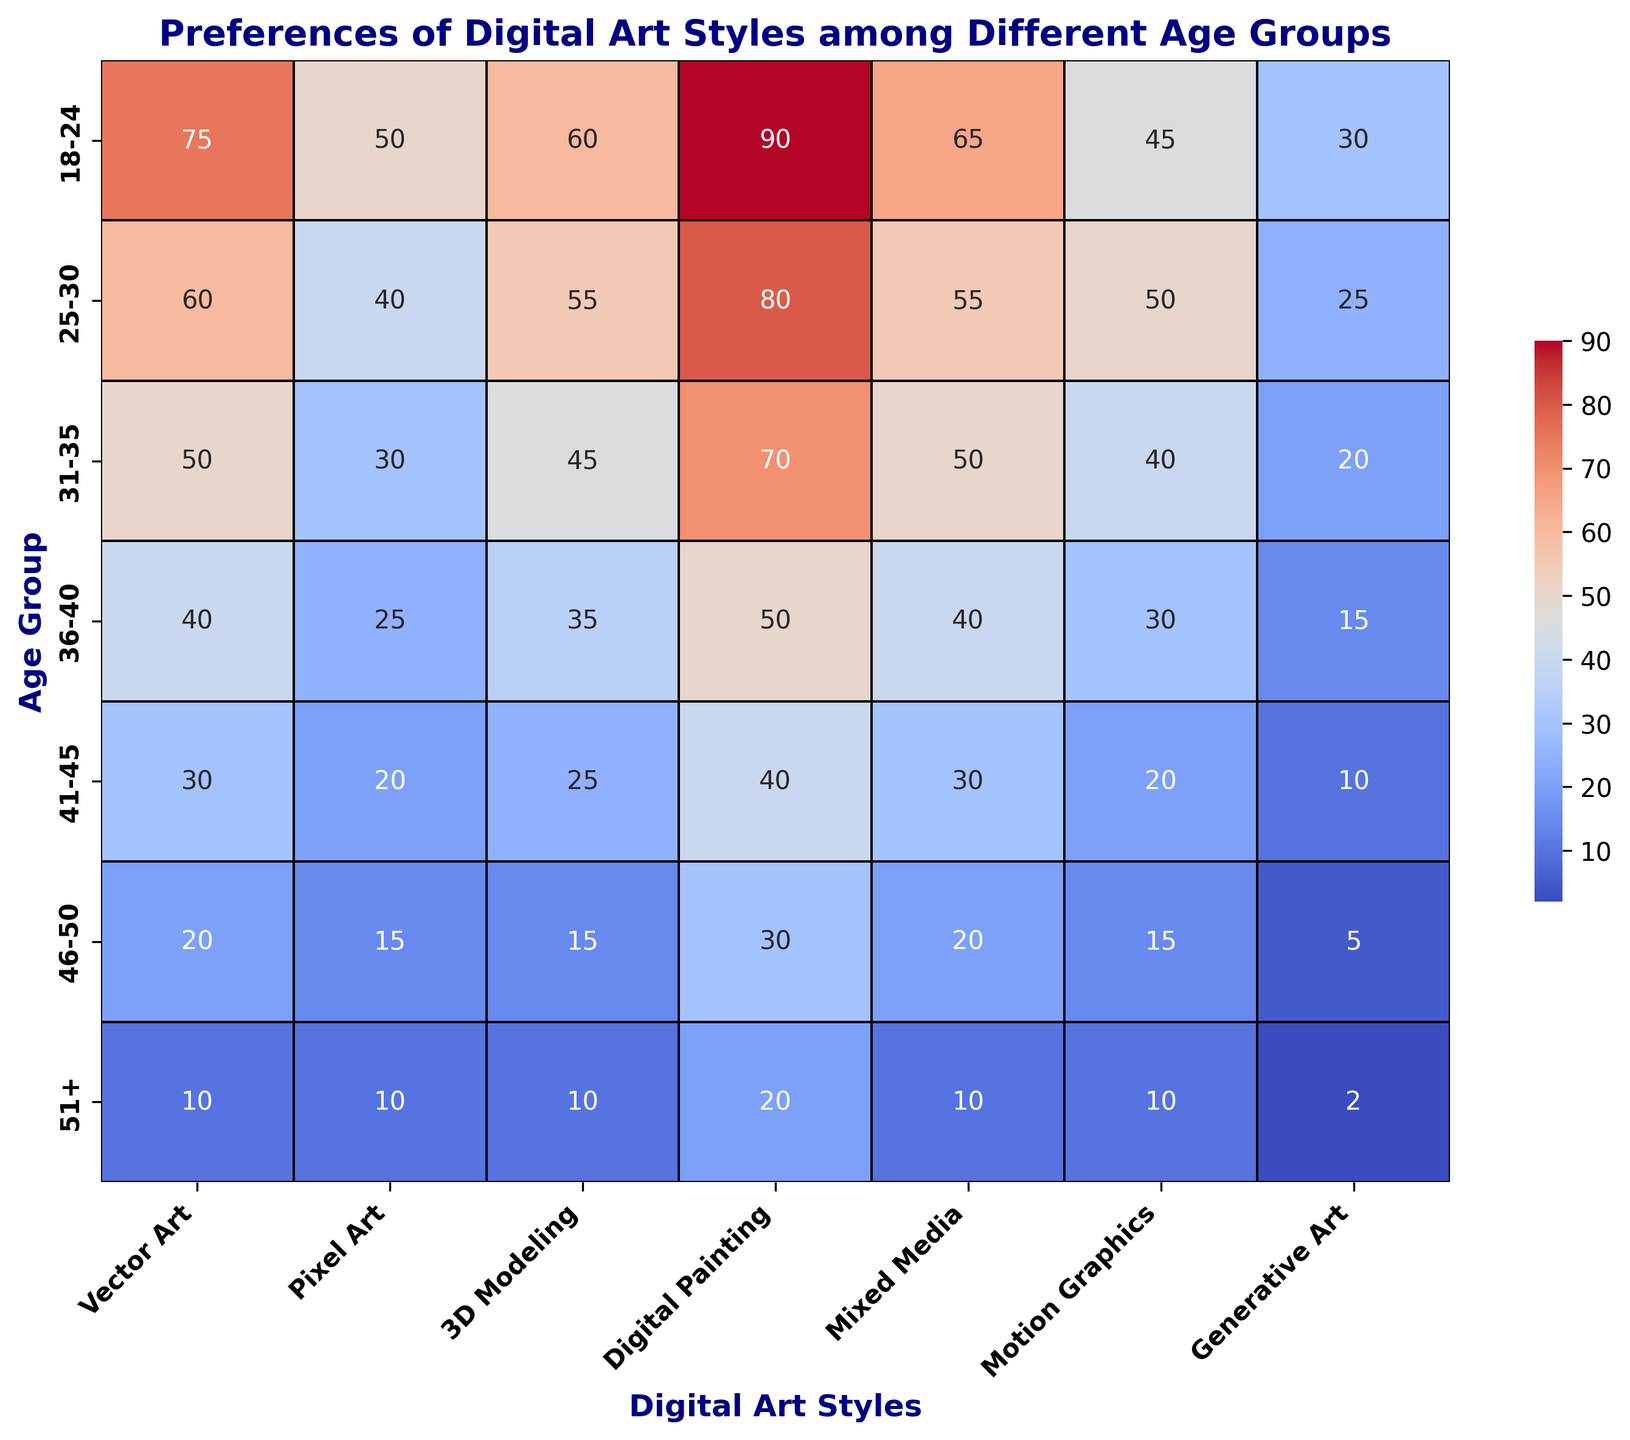Which age group has the highest preference for Digital Painting? The heatmap shows the preference for Digital Painting by different age groups. The darkest red cell under the "Digital Painting" column is for the "18-24" age group, indicating the highest value.
Answer: 18-24 Which digital art style is most preferred by the age group 25-30? Looking at the row for the "25-30" age group, the highest number is under the "Digital Painting" column, which is the darkest red cell in that row.
Answer: Digital Painting What is the difference in preference for Motion Graphics between age groups 18-24 and 41-45? The heatmap shows the preferences for Motion Graphics as 45 for 18-24 age group and 20 for 41-45 age group. The difference is 45 - 20 = 25.
Answer: 25 Which digital art styles do the age group 36-40 prefer equally? In the row for the "36-40" age group, the preferences for Generative Art and Pixel Art are both 15, indicated by similar color shades.
Answer: Generative Art and Pixel Art What is the overall trend in preference for Generative Art as age increases? The heatmap shows that the values for Generative Art decrease gradually from 30 for the 18-24 age group to 2 for the 51+ age group, visualized by the increasingly lighter shades.
Answer: Decreasing What is the combined preference for Vector Art and 3D Modeling for the age group 31-35? The heatmap shows the preference for Vector Art is 50 and for 3D Modeling is 45 in the 31-35 age group. The sum is 50 + 45 = 95.
Answer: 95 Which age group has the least preference for Mixed Media? The heatmap shows the lowest value in the "Mixed Media" column is for the "51+" age group with a preference of 10, indicated by the lightest shade.
Answer: 51+ What’s the total preference for digital art styles in the age group 46-50? The row for the "46-50" age group shows the preferences as 20 + 15 + 15 + 30 + 20 + 15 + 5 = 120.
Answer: 120 Which digital art style has the most steady preference across all age groups? By observing the heatmap, Digital Painting shows relatively high and consistent values (90, 80, 70, 50, 40, 30, 20), indicated by the consistent darker shades compared to other styles.
Answer: Digital Painting How does the preference for Pixel Art change from 18-24 to 36-40? The heatmap shows the values for Pixel Art as 50 in the 18-24 group, 40 in 25-30, 30 in 31-35, and 25 in 36-40. The pattern shows a decrease.
Answer: Decreasing 